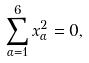Convert formula to latex. <formula><loc_0><loc_0><loc_500><loc_500>\sum _ { \alpha = 1 } ^ { 6 } x _ { \alpha } ^ { 2 } = 0 ,</formula> 